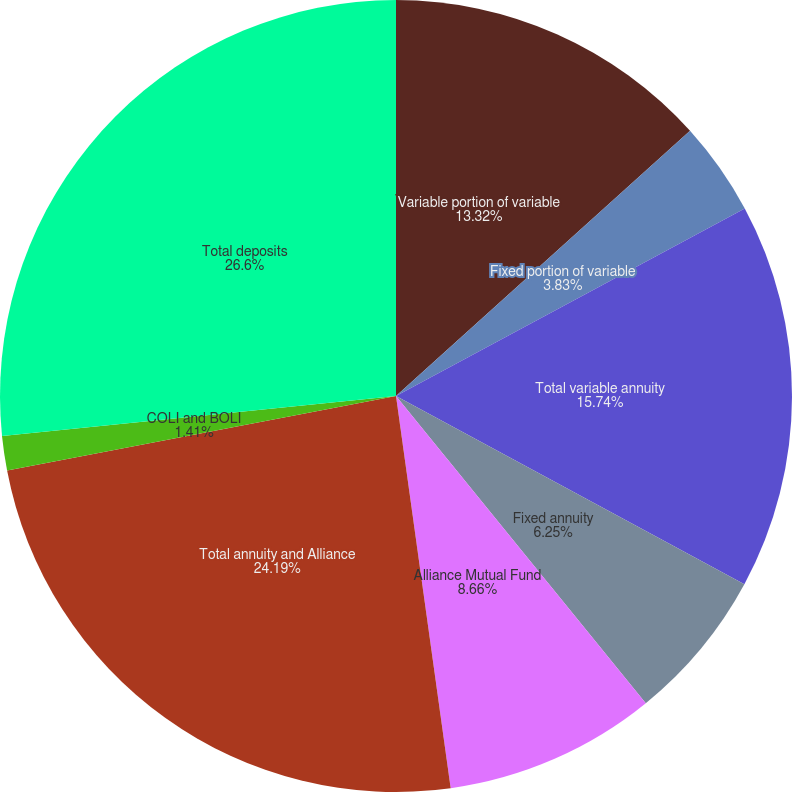<chart> <loc_0><loc_0><loc_500><loc_500><pie_chart><fcel>Variable portion of variable<fcel>Fixed portion of variable<fcel>Total variable annuity<fcel>Fixed annuity<fcel>Alliance Mutual Fund<fcel>Total annuity and Alliance<fcel>COLI and BOLI<fcel>Total deposits<nl><fcel>13.32%<fcel>3.83%<fcel>15.74%<fcel>6.25%<fcel>8.66%<fcel>24.19%<fcel>1.41%<fcel>26.61%<nl></chart> 